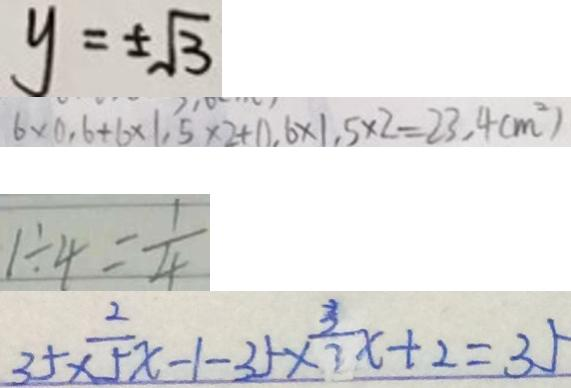<formula> <loc_0><loc_0><loc_500><loc_500>y = \pm \sqrt { 3 } 
 6 \times ( 0 . 6 + 1 6 \times 1 . 5 \times 2 + 0 . 6 \times 1 . 5 \times 2 = 2 3 . 4 ( m ^ { 2 } ) 
 1 \div 4 = \frac { 1 } { 4 } 
 3 5 \times \frac { 2 } { 5 } x - 1 - 3 5 \times \frac { 3 } { 3 } x + 2 = 3 5</formula> 